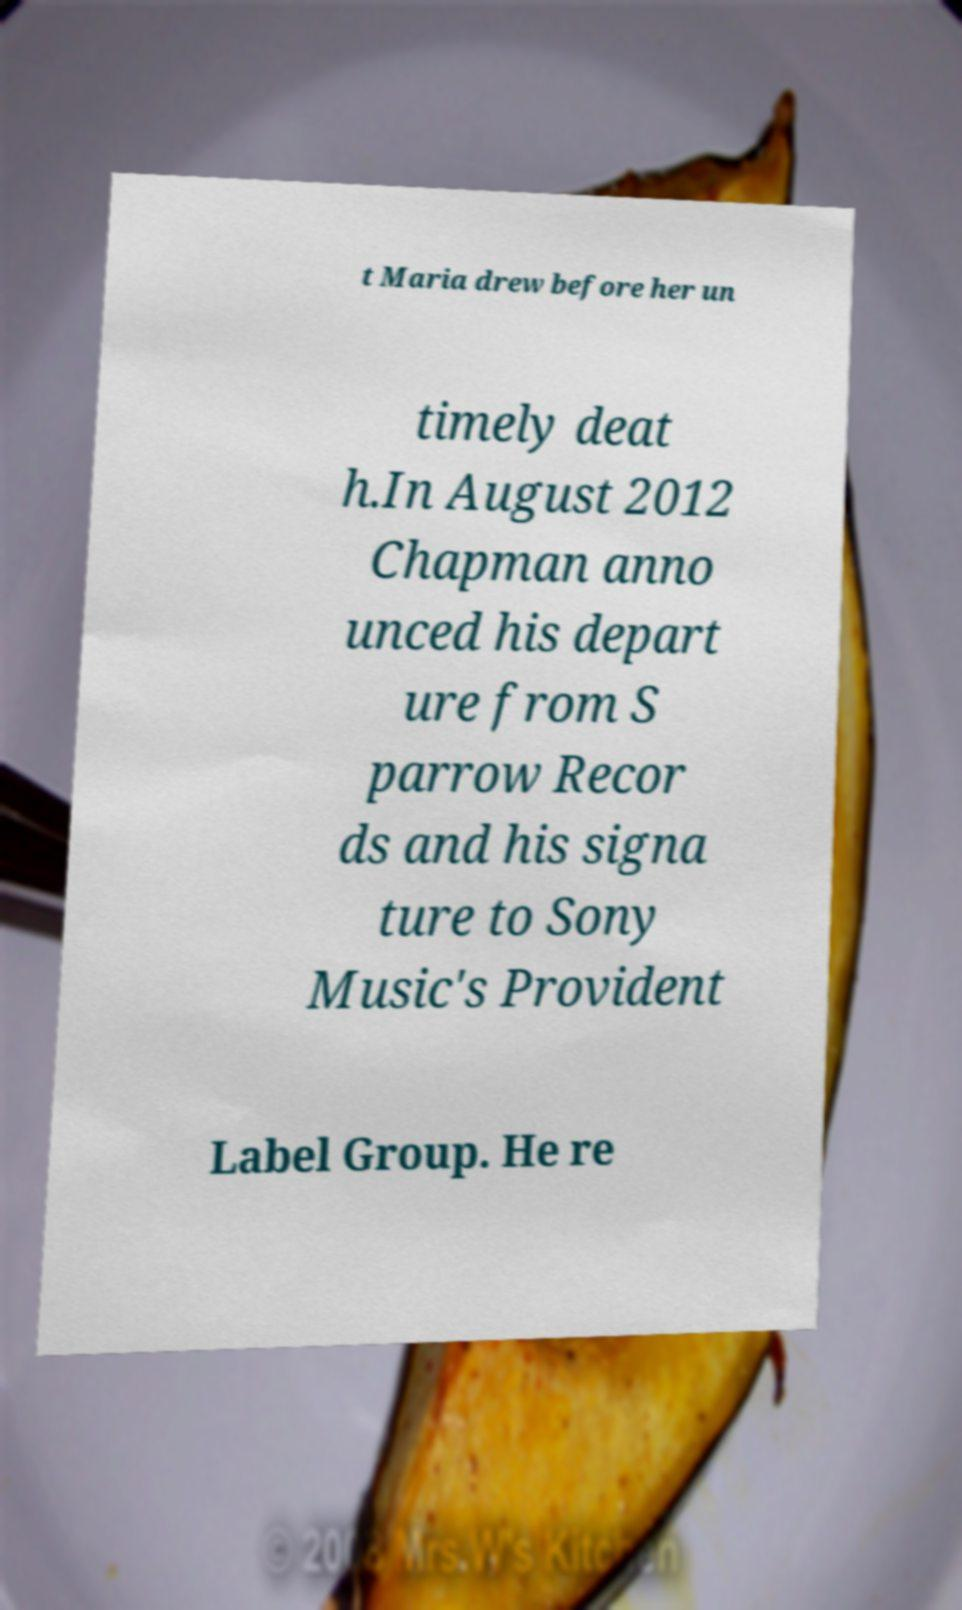Can you read and provide the text displayed in the image?This photo seems to have some interesting text. Can you extract and type it out for me? t Maria drew before her un timely deat h.In August 2012 Chapman anno unced his depart ure from S parrow Recor ds and his signa ture to Sony Music's Provident Label Group. He re 